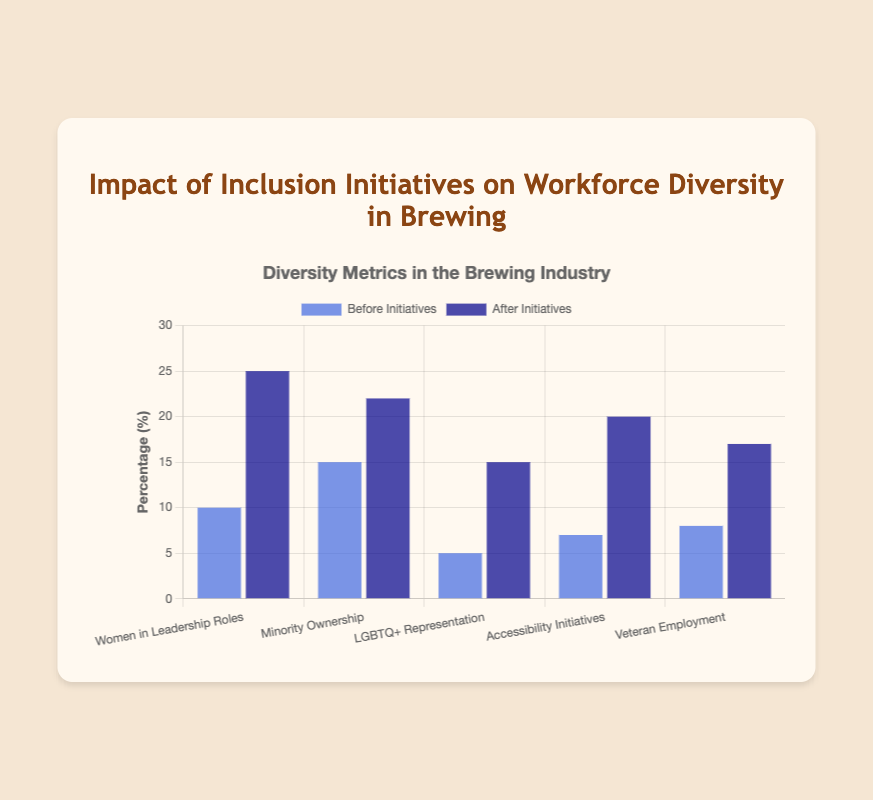Which category shows the biggest improvement after the initiatives? To find the largest improvement, subtract the "Before" data value from the "After" data value for each category. The improvements are: Women in Leadership Roles (25-10=15), Minority Ownership (22-15=7), LGBTQ+ Representation (15-5=10), Accessibility Initiatives (20-7=13), and Veteran Employment (17-8=9). The largest improvement is 15 in the Women in Leadership Roles category.
Answer: Women in Leadership Roles How much did the representation of LGBTQ+ employees increase after the initiatives? Subtract the "Before" value from the "After" value for LGBTQ+ Representation: 15 - 5 = 10.
Answer: 10 What is the total percentage of Women in Leadership Roles and Minority Ownership after the initiatives? Add the "After" values for Women in Leadership Roles and Minority Ownership: 25 + 22 = 47.
Answer: 47 Which category had the smallest change after the initiatives? To find the smallest change, we compare the differences in each category: Women in Leadership Roles (15), Minority Ownership (7), LGBTQ+ Representation (10), Accessibility Initiatives (13), and Veteran Employment (9). The smallest change is in Minority Ownership (7).
Answer: Minority Ownership Which category had a higher representation before the initiatives, Minority Ownership or Veteran Employment? Compare the "Before" values for Minority Ownership (15) and Veteran Employment (8). 15 is greater than 8.
Answer: Minority Ownership Which bar is higher for Accessibility Initiatives, Before or After the initiatives? By visually comparing the heights, the dark blue bar (After the initiatives) for Accessibility Initiatives is higher than the blue bar (Before the initiatives).
Answer: After What is the combined percentage of accessibility initiatives before and after the initiatives? Add the "Before" and "After" values for Accessibility Initiatives: 7 + 20 = 27.
Answer: 27 Which had a greater increase after the initiatives, Women in Leadership Roles or Veteran Employment? Calculate the increase for each: Women in Leadership Roles (25 - 10 = 15) and Veteran Employment (17 - 8 = 9). 15 is greater than 9.
Answer: Women in Leadership Roles 